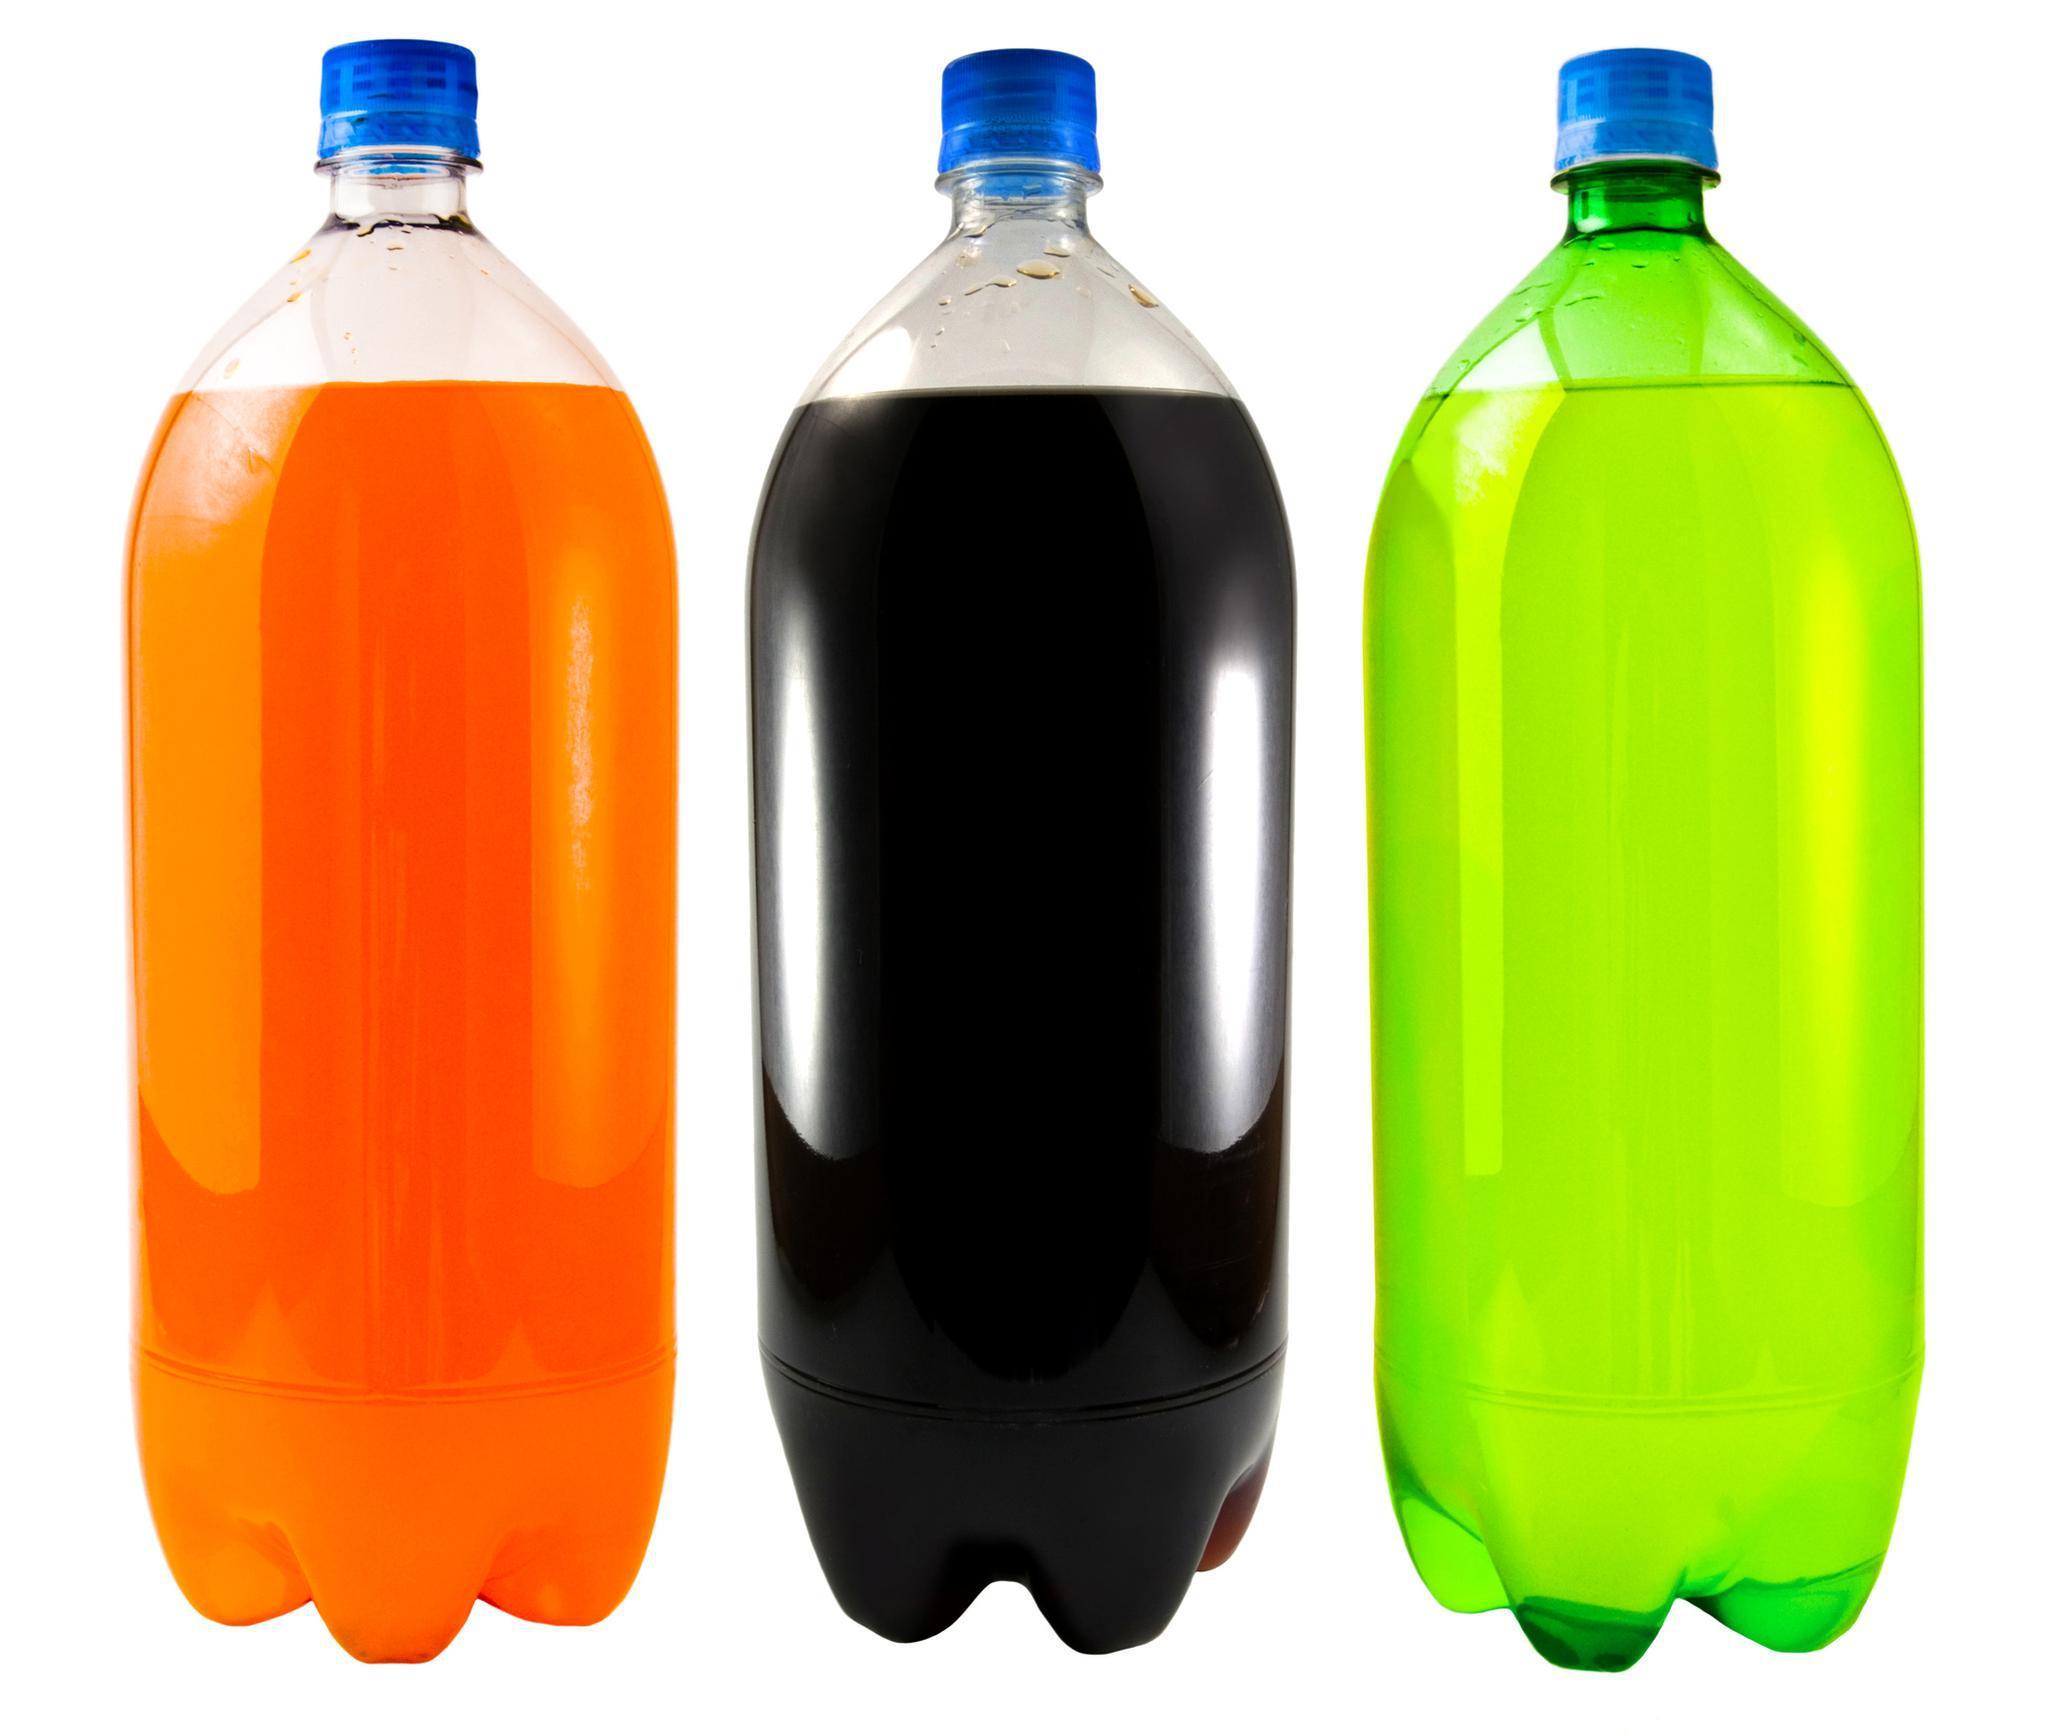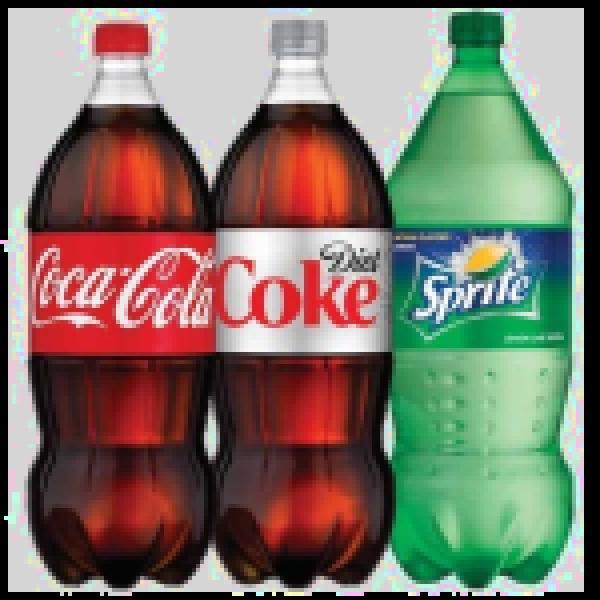The first image is the image on the left, the second image is the image on the right. For the images displayed, is the sentence "Exactly three bottles of fizzy drink can be seen in each image." factually correct? Answer yes or no. Yes. The first image is the image on the left, the second image is the image on the right. Evaluate the accuracy of this statement regarding the images: "The left image shows exactly three bottles of different colored liquids with no labels, and the right image shows three soda bottles with printed labels on the front.". Is it true? Answer yes or no. Yes. 